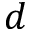<formula> <loc_0><loc_0><loc_500><loc_500>d</formula> 